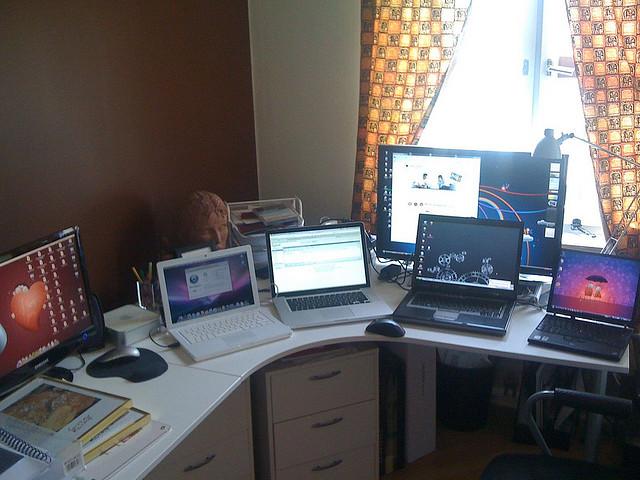How many computers?
Quick response, please. 6. How many are laptops?
Be succinct. 4. Are these all apple computers?
Keep it brief. No. What type of lamp?
Write a very short answer. Desk. 